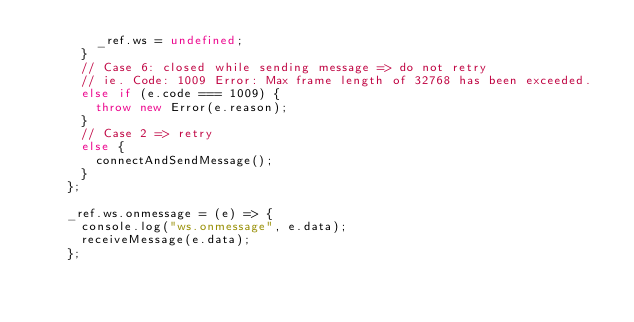Convert code to text. <code><loc_0><loc_0><loc_500><loc_500><_JavaScript_>        _ref.ws = undefined;
      }
      // Case 6: closed while sending message => do not retry
      // ie. Code: 1009 Error: Max frame length of 32768 has been exceeded.
      else if (e.code === 1009) {
        throw new Error(e.reason);
      }
      // Case 2 => retry
      else {
        connectAndSendMessage();
      }
    };

    _ref.ws.onmessage = (e) => {
      console.log("ws.onmessage", e.data);
      receiveMessage(e.data);
    };
</code> 